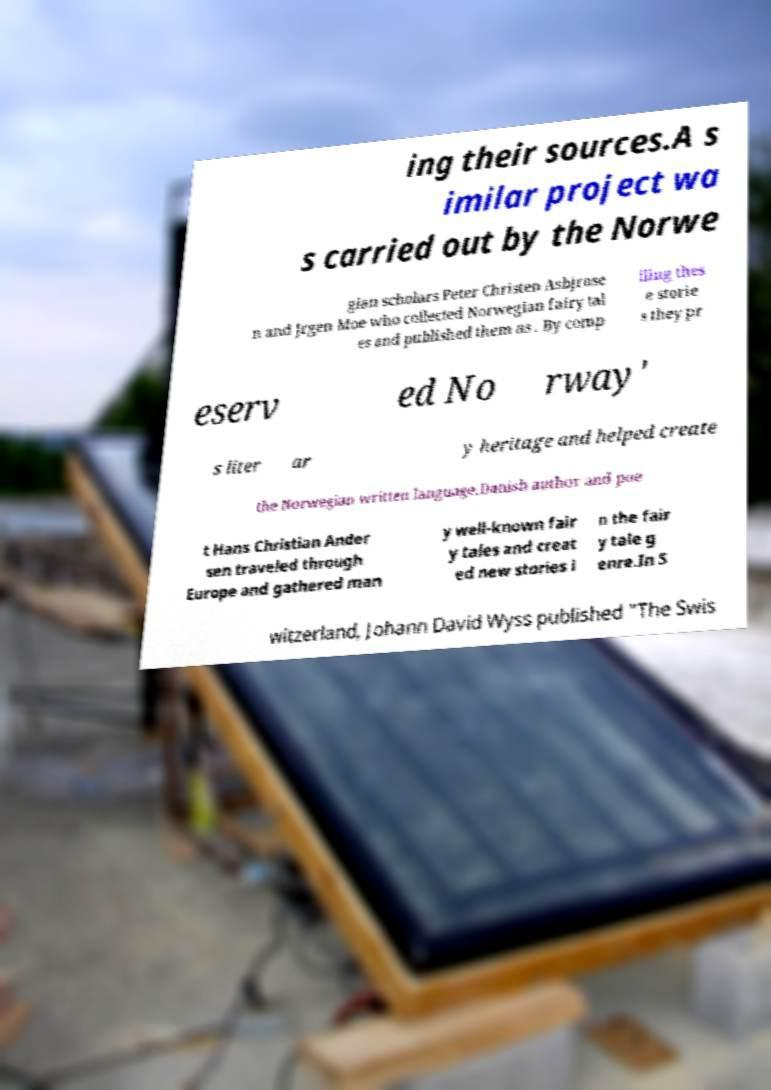There's text embedded in this image that I need extracted. Can you transcribe it verbatim? ing their sources.A s imilar project wa s carried out by the Norwe gian scholars Peter Christen Asbjrnse n and Jrgen Moe who collected Norwegian fairy tal es and published them as . By comp iling thes e storie s they pr eserv ed No rway' s liter ar y heritage and helped create the Norwegian written language.Danish author and poe t Hans Christian Ander sen traveled through Europe and gathered man y well-known fair y tales and creat ed new stories i n the fair y tale g enre.In S witzerland, Johann David Wyss published "The Swis 